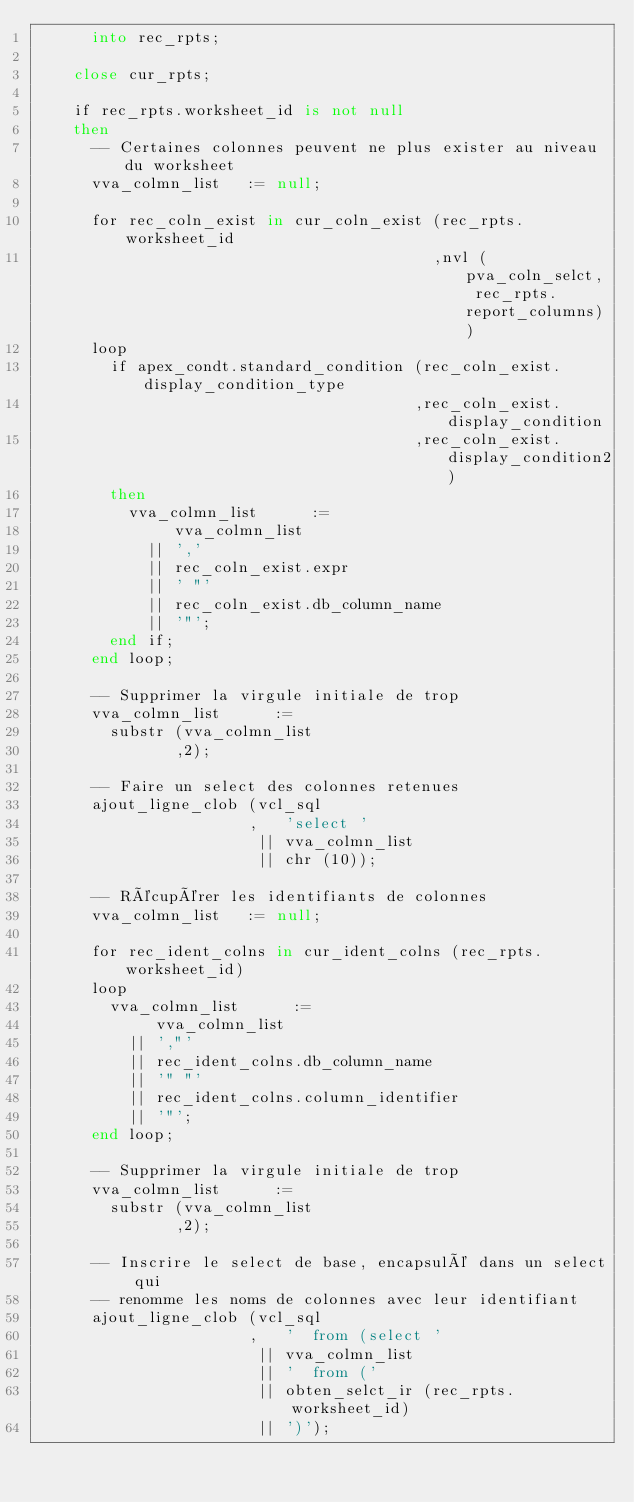Convert code to text. <code><loc_0><loc_0><loc_500><loc_500><_SQL_>      into rec_rpts;

    close cur_rpts;

    if rec_rpts.worksheet_id is not null
    then
      -- Certaines colonnes peuvent ne plus exister au niveau du worksheet
      vva_colmn_list   := null;

      for rec_coln_exist in cur_coln_exist (rec_rpts.worksheet_id
                                           ,nvl (pva_coln_selct, rec_rpts.report_columns))
      loop
        if apex_condt.standard_condition (rec_coln_exist.display_condition_type
                                         ,rec_coln_exist.display_condition
                                         ,rec_coln_exist.display_condition2)
        then
          vva_colmn_list      :=
               vva_colmn_list
            || ','
            || rec_coln_exist.expr
            || ' "'
            || rec_coln_exist.db_column_name
            || '"';
        end if;
      end loop;

      -- Supprimer la virgule initiale de trop
      vva_colmn_list      :=
        substr (vva_colmn_list
               ,2);

      -- Faire un select des colonnes retenues
      ajout_ligne_clob (vcl_sql
                       ,   'select '
                        || vva_colmn_list
                        || chr (10));

      -- Récupérer les identifiants de colonnes
      vva_colmn_list   := null;

      for rec_ident_colns in cur_ident_colns (rec_rpts.worksheet_id)
      loop
        vva_colmn_list      :=
             vva_colmn_list
          || ',"'
          || rec_ident_colns.db_column_name
          || '" "'
          || rec_ident_colns.column_identifier
          || '"';
      end loop;

      -- Supprimer la virgule initiale de trop
      vva_colmn_list      :=
        substr (vva_colmn_list
               ,2);

      -- Inscrire le select de base, encapsulé dans un select qui
      -- renomme les noms de colonnes avec leur identifiant
      ajout_ligne_clob (vcl_sql
                       ,   '  from (select '
                        || vva_colmn_list
                        || '  from ('
                        || obten_selct_ir (rec_rpts.worksheet_id)
                        || ')');
</code> 